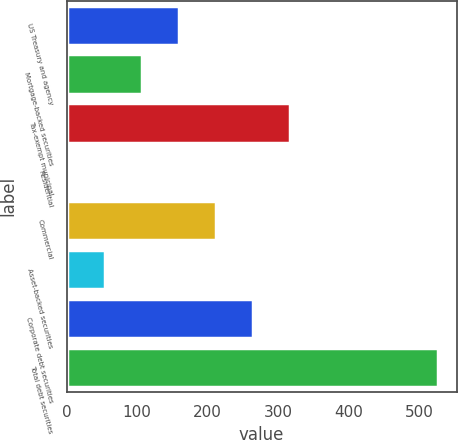Convert chart. <chart><loc_0><loc_0><loc_500><loc_500><bar_chart><fcel>US Treasury and agency<fcel>Mortgage-backed securities<fcel>Tax-exempt municipal<fcel>Residential<fcel>Commercial<fcel>Asset-backed securities<fcel>Corporate debt securities<fcel>Total debt securities<nl><fcel>159.27<fcel>106.74<fcel>316.86<fcel>1.68<fcel>211.8<fcel>54.21<fcel>264.33<fcel>527<nl></chart> 